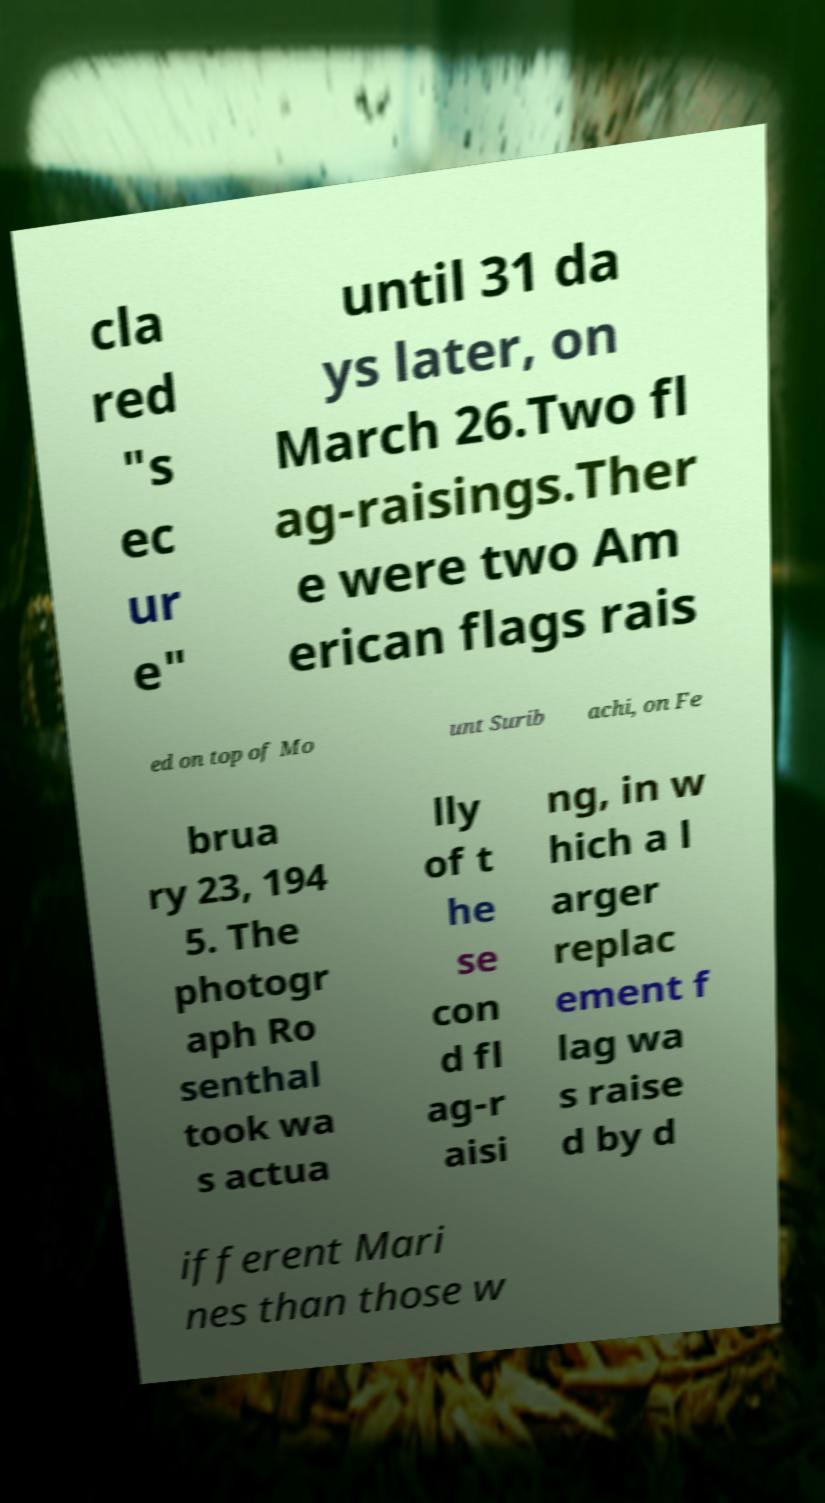Please identify and transcribe the text found in this image. cla red "s ec ur e" until 31 da ys later, on March 26.Two fl ag-raisings.Ther e were two Am erican flags rais ed on top of Mo unt Surib achi, on Fe brua ry 23, 194 5. The photogr aph Ro senthal took wa s actua lly of t he se con d fl ag-r aisi ng, in w hich a l arger replac ement f lag wa s raise d by d ifferent Mari nes than those w 